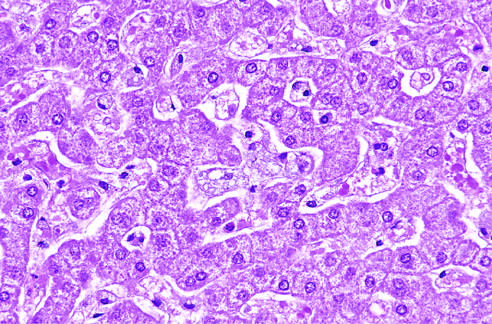what have a foamy, vacuolated appearance resulting from deposition of lipids?
Answer the question using a single word or phrase. The hepatocytes and kupffer cells 